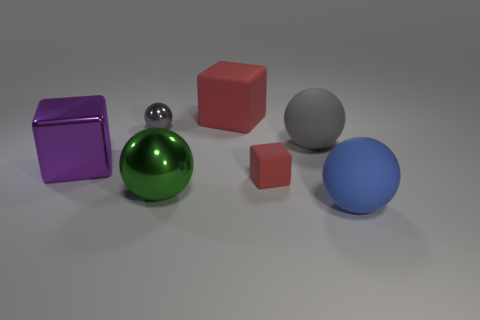Subtract all red cubes. How many gray balls are left? 2 Subtract all tiny rubber cubes. How many cubes are left? 2 Subtract 1 cubes. How many cubes are left? 2 Add 2 tiny blue metallic things. How many objects exist? 9 Subtract all blue spheres. How many spheres are left? 3 Subtract 0 brown cylinders. How many objects are left? 7 Subtract all balls. How many objects are left? 3 Subtract all blue spheres. Subtract all gray cylinders. How many spheres are left? 3 Subtract all small gray things. Subtract all rubber objects. How many objects are left? 2 Add 3 purple shiny objects. How many purple shiny objects are left? 4 